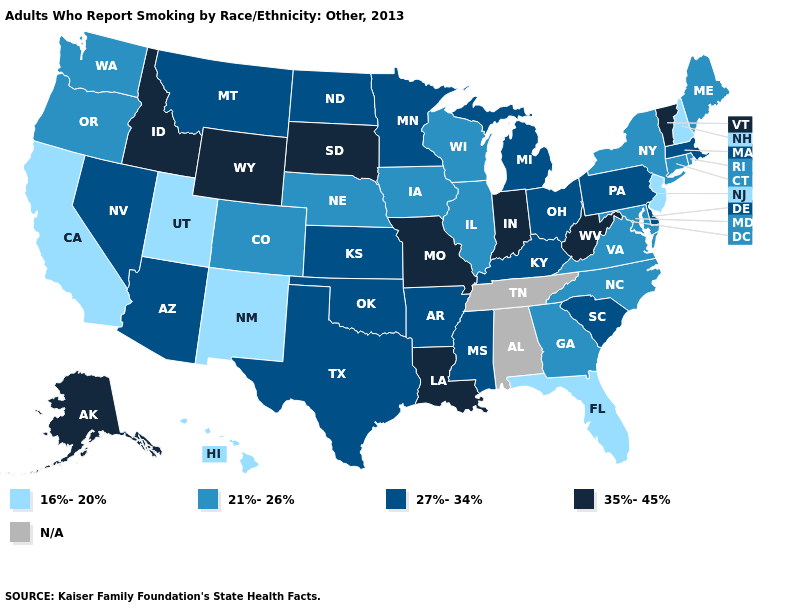Does New York have the highest value in the Northeast?
Give a very brief answer. No. Which states have the highest value in the USA?
Give a very brief answer. Alaska, Idaho, Indiana, Louisiana, Missouri, South Dakota, Vermont, West Virginia, Wyoming. Among the states that border Louisiana , which have the highest value?
Write a very short answer. Arkansas, Mississippi, Texas. What is the highest value in the USA?
Be succinct. 35%-45%. What is the value of Mississippi?
Quick response, please. 27%-34%. What is the value of South Carolina?
Keep it brief. 27%-34%. What is the value of Arizona?
Answer briefly. 27%-34%. Does the first symbol in the legend represent the smallest category?
Quick response, please. Yes. Which states have the highest value in the USA?
Concise answer only. Alaska, Idaho, Indiana, Louisiana, Missouri, South Dakota, Vermont, West Virginia, Wyoming. Among the states that border Kentucky , does West Virginia have the lowest value?
Short answer required. No. Does Delaware have the lowest value in the South?
Answer briefly. No. Name the states that have a value in the range 21%-26%?
Be succinct. Colorado, Connecticut, Georgia, Illinois, Iowa, Maine, Maryland, Nebraska, New York, North Carolina, Oregon, Rhode Island, Virginia, Washington, Wisconsin. Name the states that have a value in the range 21%-26%?
Give a very brief answer. Colorado, Connecticut, Georgia, Illinois, Iowa, Maine, Maryland, Nebraska, New York, North Carolina, Oregon, Rhode Island, Virginia, Washington, Wisconsin. What is the value of Hawaii?
Give a very brief answer. 16%-20%. What is the highest value in states that border Minnesota?
Give a very brief answer. 35%-45%. 